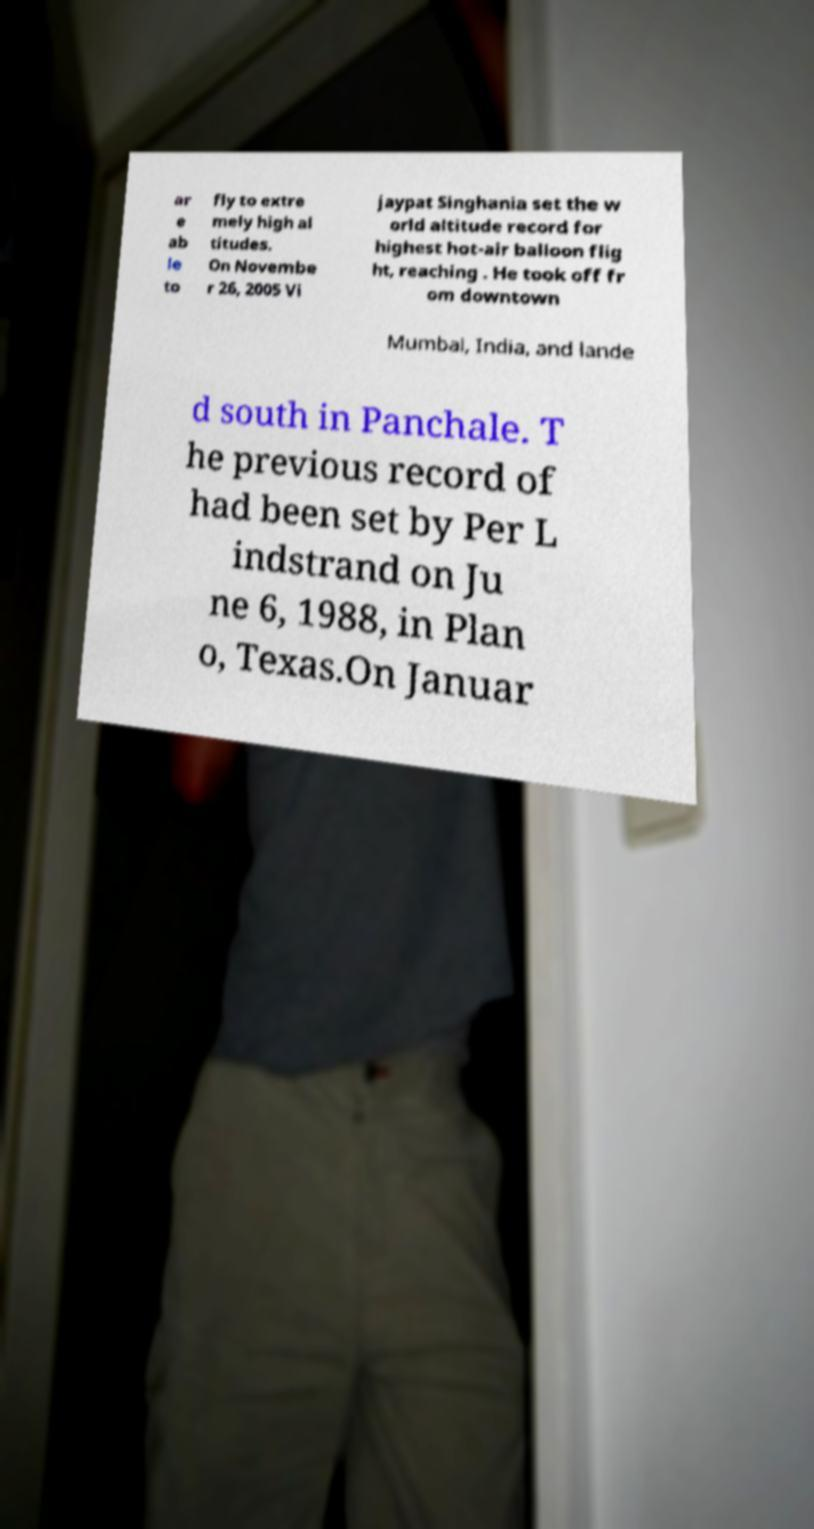For documentation purposes, I need the text within this image transcribed. Could you provide that? ar e ab le to fly to extre mely high al titudes. On Novembe r 26, 2005 Vi jaypat Singhania set the w orld altitude record for highest hot-air balloon flig ht, reaching . He took off fr om downtown Mumbai, India, and lande d south in Panchale. T he previous record of had been set by Per L indstrand on Ju ne 6, 1988, in Plan o, Texas.On Januar 